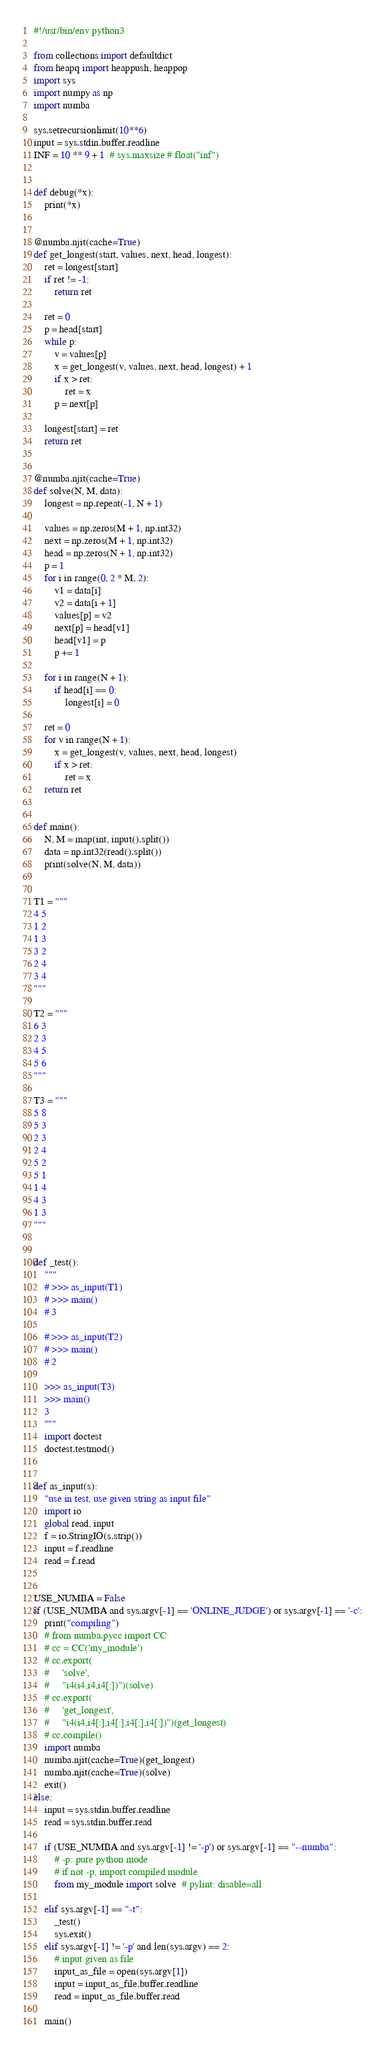Convert code to text. <code><loc_0><loc_0><loc_500><loc_500><_Python_>#!/usr/bin/env python3

from collections import defaultdict
from heapq import heappush, heappop
import sys
import numpy as np
import numba

sys.setrecursionlimit(10**6)
input = sys.stdin.buffer.readline
INF = 10 ** 9 + 1  # sys.maxsize # float("inf")


def debug(*x):
    print(*x)


@numba.njit(cache=True)
def get_longest(start, values, next, head, longest):
    ret = longest[start]
    if ret != -1:
        return ret

    ret = 0
    p = head[start]
    while p:
        v = values[p]
        x = get_longest(v, values, next, head, longest) + 1
        if x > ret:
            ret = x
        p = next[p]

    longest[start] = ret
    return ret


@numba.njit(cache=True)
def solve(N, M, data):
    longest = np.repeat(-1, N + 1)

    values = np.zeros(M + 1, np.int32)
    next = np.zeros(M + 1, np.int32)
    head = np.zeros(N + 1, np.int32)
    p = 1
    for i in range(0, 2 * M, 2):
        v1 = data[i]
        v2 = data[i + 1]
        values[p] = v2
        next[p] = head[v1]
        head[v1] = p
        p += 1

    for i in range(N + 1):
        if head[i] == 0:
            longest[i] = 0

    ret = 0
    for v in range(N + 1):
        x = get_longest(v, values, next, head, longest)
        if x > ret:
            ret = x
    return ret


def main():
    N, M = map(int, input().split())
    data = np.int32(read().split())
    print(solve(N, M, data))


T1 = """
4 5
1 2
1 3
3 2
2 4
3 4
"""

T2 = """
6 3
2 3
4 5
5 6
"""

T3 = """
5 8
5 3
2 3
2 4
5 2
5 1
1 4
4 3
1 3
"""


def _test():
    """
    # >>> as_input(T1)
    # >>> main()
    # 3

    # >>> as_input(T2)
    # >>> main()
    # 2

    >>> as_input(T3)
    >>> main()
    3
    """
    import doctest
    doctest.testmod()


def as_input(s):
    "use in test, use given string as input file"
    import io
    global read, input
    f = io.StringIO(s.strip())
    input = f.readline
    read = f.read


USE_NUMBA = False
if (USE_NUMBA and sys.argv[-1] == 'ONLINE_JUDGE') or sys.argv[-1] == '-c':
    print("compiling")
    # from numba.pycc import CC
    # cc = CC('my_module')
    # cc.export(
    #     'solve',
    #     "i4(i4,i4,i4[:])")(solve)
    # cc.export(
    #     'get_longest',
    #     "i4(i4,i4[:],i4[:],i4[:],i4[:])")(get_longest)
    # cc.compile()
    import numba
    numba.njit(cache=True)(get_longest)
    numba.njit(cache=True)(solve)
    exit()
else:
    input = sys.stdin.buffer.readline
    read = sys.stdin.buffer.read

    if (USE_NUMBA and sys.argv[-1] != '-p') or sys.argv[-1] == "--numba":
        # -p: pure python mode
        # if not -p, import compiled module
        from my_module import solve  # pylint: disable=all

    elif sys.argv[-1] == "-t":
        _test()
        sys.exit()
    elif sys.argv[-1] != '-p' and len(sys.argv) == 2:
        # input given as file
        input_as_file = open(sys.argv[1])
        input = input_as_file.buffer.readline
        read = input_as_file.buffer.read

    main()
</code> 